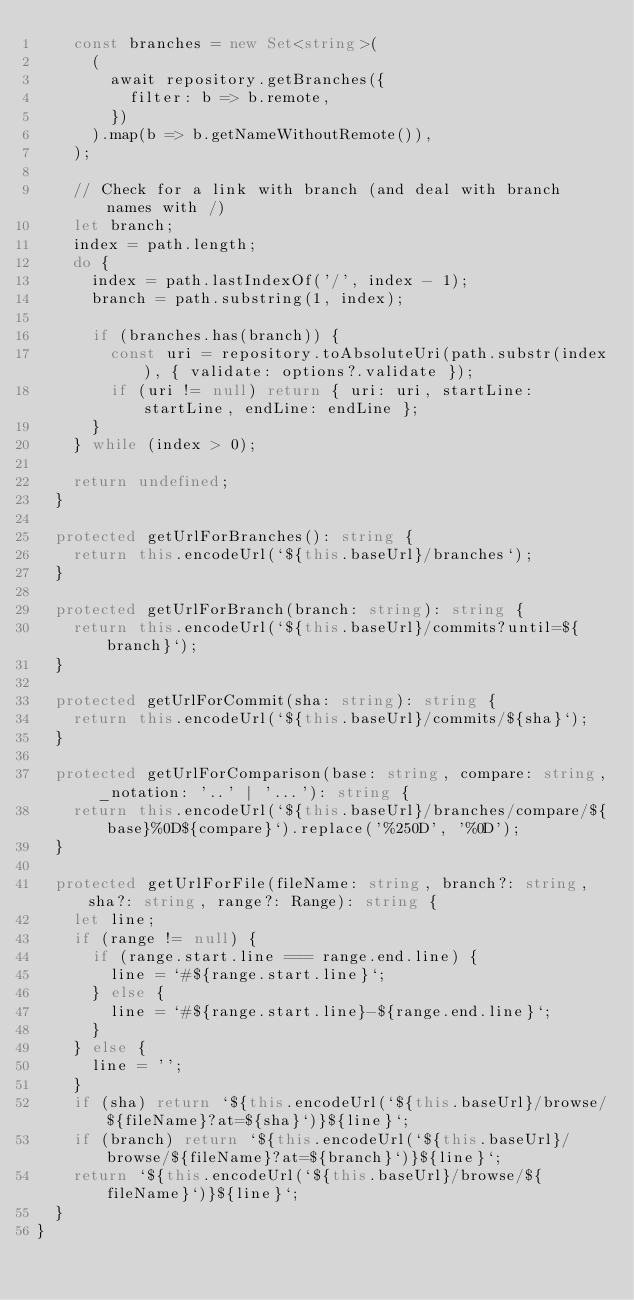Convert code to text. <code><loc_0><loc_0><loc_500><loc_500><_TypeScript_>		const branches = new Set<string>(
			(
				await repository.getBranches({
					filter: b => b.remote,
				})
			).map(b => b.getNameWithoutRemote()),
		);

		// Check for a link with branch (and deal with branch names with /)
		let branch;
		index = path.length;
		do {
			index = path.lastIndexOf('/', index - 1);
			branch = path.substring(1, index);

			if (branches.has(branch)) {
				const uri = repository.toAbsoluteUri(path.substr(index), { validate: options?.validate });
				if (uri != null) return { uri: uri, startLine: startLine, endLine: endLine };
			}
		} while (index > 0);

		return undefined;
	}

	protected getUrlForBranches(): string {
		return this.encodeUrl(`${this.baseUrl}/branches`);
	}

	protected getUrlForBranch(branch: string): string {
		return this.encodeUrl(`${this.baseUrl}/commits?until=${branch}`);
	}

	protected getUrlForCommit(sha: string): string {
		return this.encodeUrl(`${this.baseUrl}/commits/${sha}`);
	}

	protected getUrlForComparison(base: string, compare: string, _notation: '..' | '...'): string {
		return this.encodeUrl(`${this.baseUrl}/branches/compare/${base}%0D${compare}`).replace('%250D', '%0D');
	}

	protected getUrlForFile(fileName: string, branch?: string, sha?: string, range?: Range): string {
		let line;
		if (range != null) {
			if (range.start.line === range.end.line) {
				line = `#${range.start.line}`;
			} else {
				line = `#${range.start.line}-${range.end.line}`;
			}
		} else {
			line = '';
		}
		if (sha) return `${this.encodeUrl(`${this.baseUrl}/browse/${fileName}?at=${sha}`)}${line}`;
		if (branch) return `${this.encodeUrl(`${this.baseUrl}/browse/${fileName}?at=${branch}`)}${line}`;
		return `${this.encodeUrl(`${this.baseUrl}/browse/${fileName}`)}${line}`;
	}
}
</code> 